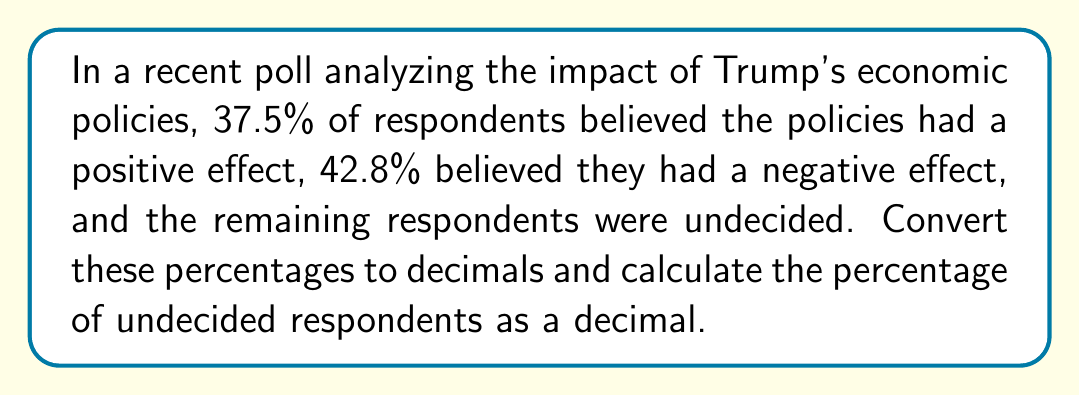Show me your answer to this math problem. To solve this problem, we need to follow these steps:

1. Convert the given percentages to decimals:
   To convert a percentage to a decimal, we divide by 100 or move the decimal point two places to the left.

   37.5% = $\frac{37.5}{100} = 0.375$
   42.8% = $\frac{42.8}{100} = 0.428$

2. Calculate the sum of the given percentages:
   $0.375 + 0.428 = 0.803$

3. Subtract this sum from 1 to find the decimal representation of undecided respondents:
   $1 - 0.803 = 0.197$

Therefore, the percentage of undecided respondents as a decimal is 0.197.

This process is particularly useful for political bloggers analyzing poll data, as working with decimals can simplify calculations and data visualization when comparing multiple poll results or tracking changes over time.
Answer: 0.197 